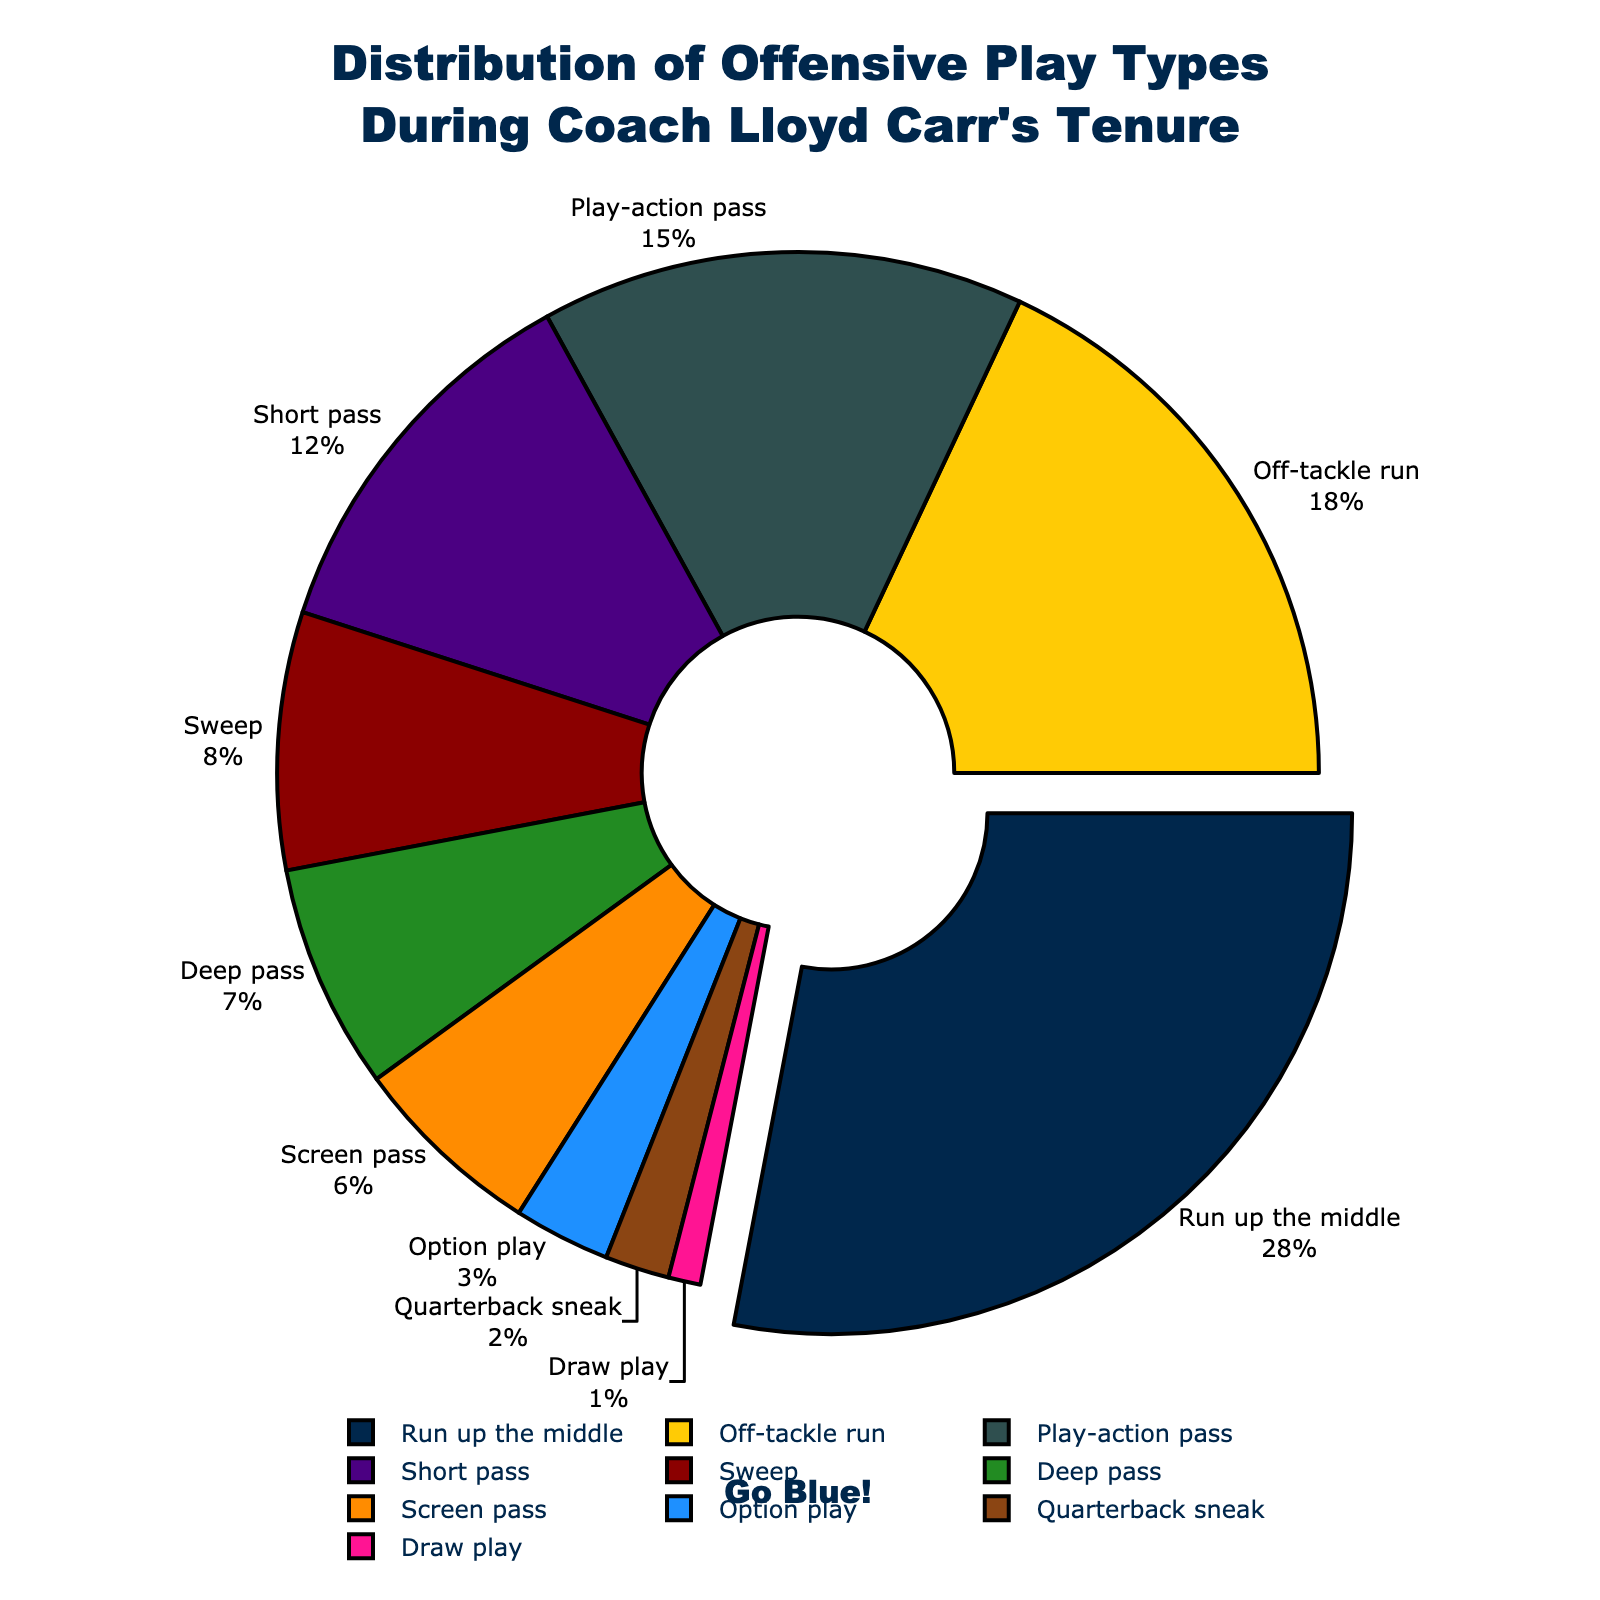Which play type has the highest percentage? The play type with the highest percentage is determined by identifying the largest slice of the pie chart. The "Run up the middle" play type makes up 28% of the total.
Answer: Run up the middle What is the combined percentage of play-action pass and deep pass plays? To find the combined percentage, add the percentages of "Play-action pass" and "Deep pass". They are 15% and 7% respectively. So, 15% + 7% = 22%.
Answer: 22% Which has a higher percentage: off-tackle run or short pass? Compare the percentages of "Off-tackle run" and "Short pass" from the pie chart. "Off-tackle run" is 18% and "Short pass" is 12%. Since 18% is greater than 12%, "Off-tackle run" has a higher percentage.
Answer: Off-tackle run What is the percentage difference between option play and draw play? Subtract the percentage of "Draw play" from the percentage of "Option play". "Option play" is 3% and "Draw play" is 1%. So, 3% - 1% = 2%.
Answer: 2% How does the size of the screen pass slice compare visually to the quarterback sneak slice? By visually inspecting the pie chart, the "Screen pass" slice is larger than the "Quarterback sneak" slice. The "Screen pass" is 6%, while "Quarterback sneak" is 2%.
Answer: Larger Which play type is indicated by the largest pulled-out slice? The largest pulled-out slice represents the play type with the highest percentage. Visually identified from the chart, it is the "Run up the middle" play type.
Answer: Run up the middle What is the total percentage of all pass plays combined (play-action pass, short pass, deep pass, screen pass)? Add the percentages of all the individual pass plays: "Play-action pass" (15%), "Short pass" (12%), "Deep pass" (7%), and "Screen pass" (6%). So, 15% + 12% + 7% + 6% = 40%.
Answer: 40% Which two play types have the closest percentage values? By comparing the percentages visually, "Sweep" (8%) and "Deep pass" (7%) have the closest values, with a difference of 1%.
Answer: Sweep, Deep pass 